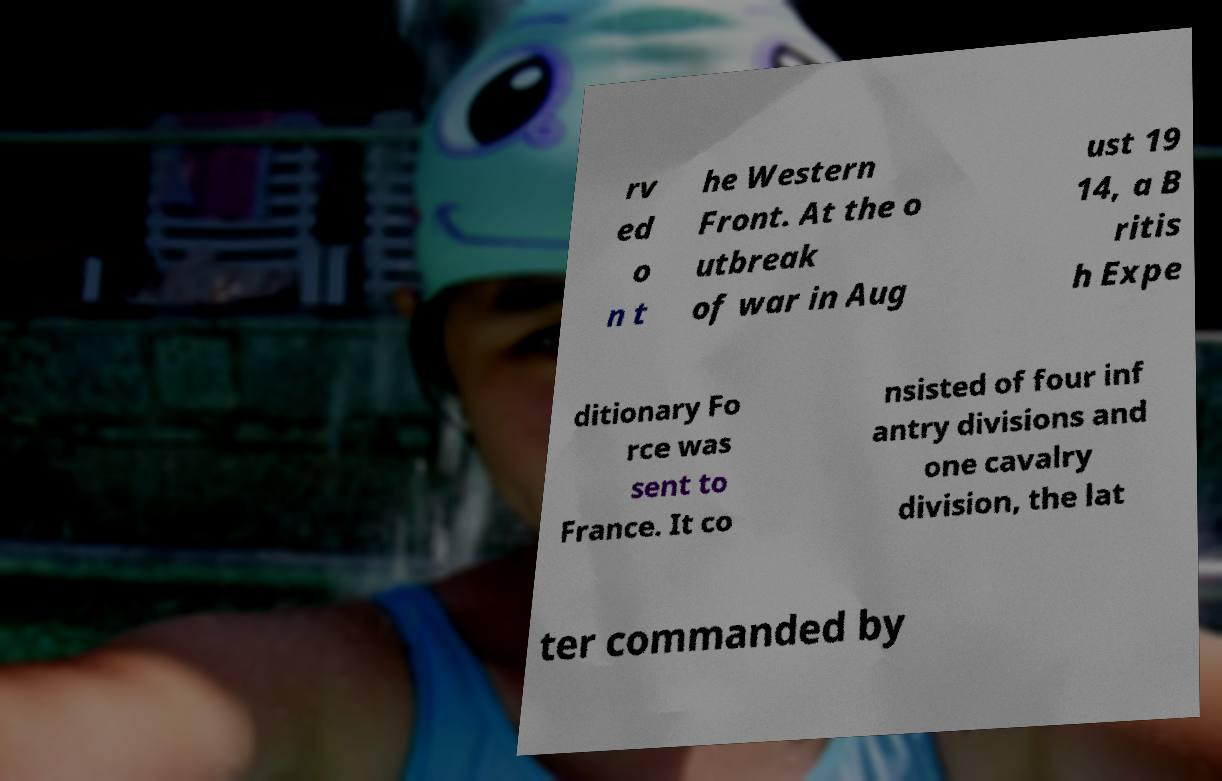Please identify and transcribe the text found in this image. rv ed o n t he Western Front. At the o utbreak of war in Aug ust 19 14, a B ritis h Expe ditionary Fo rce was sent to France. It co nsisted of four inf antry divisions and one cavalry division, the lat ter commanded by 